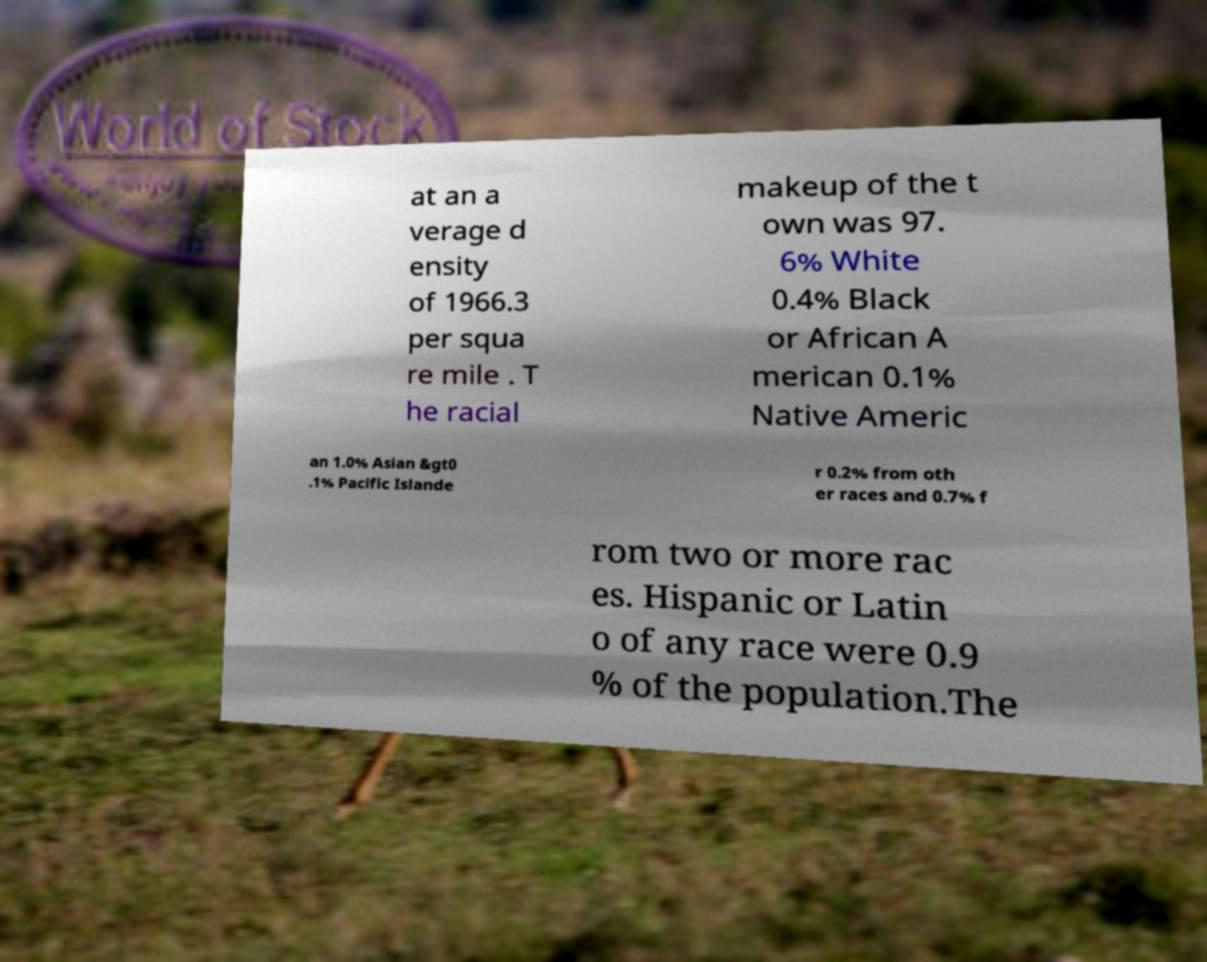Could you extract and type out the text from this image? at an a verage d ensity of 1966.3 per squa re mile . T he racial makeup of the t own was 97. 6% White 0.4% Black or African A merican 0.1% Native Americ an 1.0% Asian &gt0 .1% Pacific Islande r 0.2% from oth er races and 0.7% f rom two or more rac es. Hispanic or Latin o of any race were 0.9 % of the population.The 